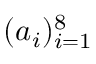<formula> <loc_0><loc_0><loc_500><loc_500>( a _ { i } ) _ { i = 1 } ^ { 8 }</formula> 